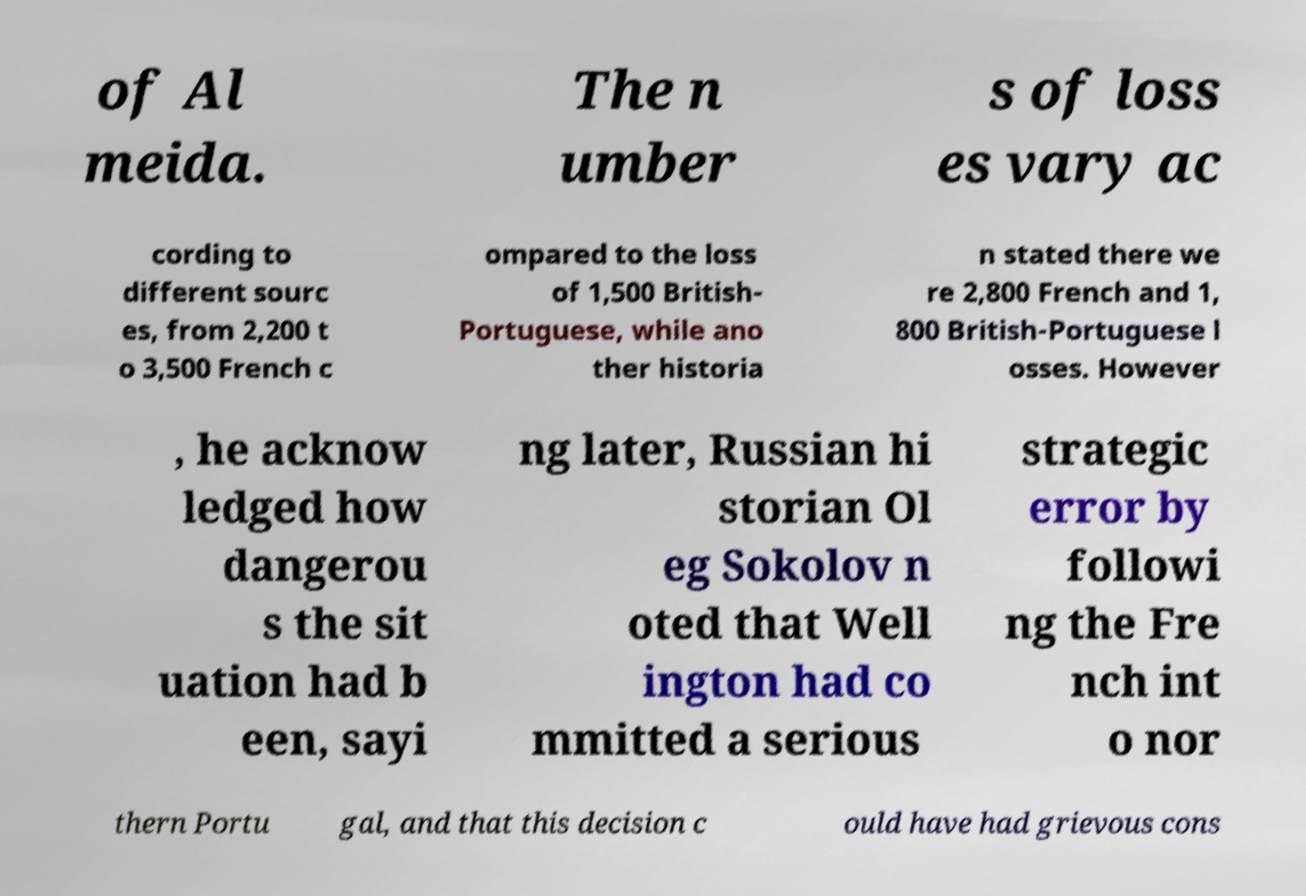For documentation purposes, I need the text within this image transcribed. Could you provide that? of Al meida. The n umber s of loss es vary ac cording to different sourc es, from 2,200 t o 3,500 French c ompared to the loss of 1,500 British- Portuguese, while ano ther historia n stated there we re 2,800 French and 1, 800 British-Portuguese l osses. However , he acknow ledged how dangerou s the sit uation had b een, sayi ng later, Russian hi storian Ol eg Sokolov n oted that Well ington had co mmitted a serious strategic error by followi ng the Fre nch int o nor thern Portu gal, and that this decision c ould have had grievous cons 